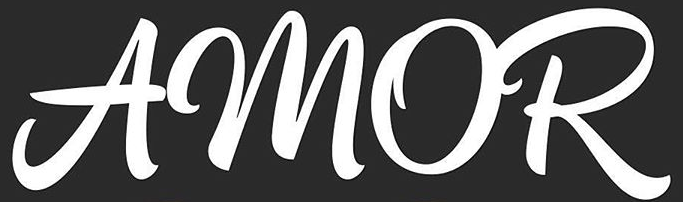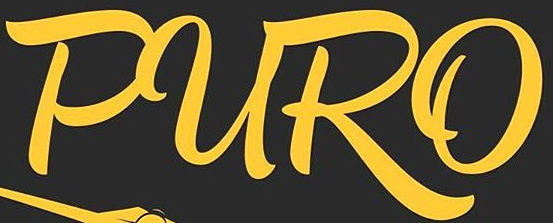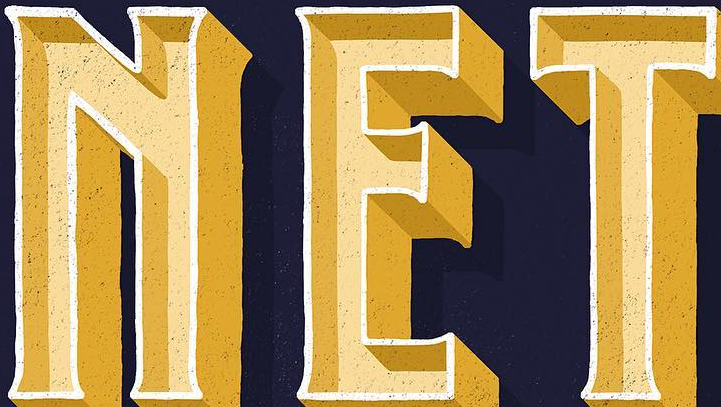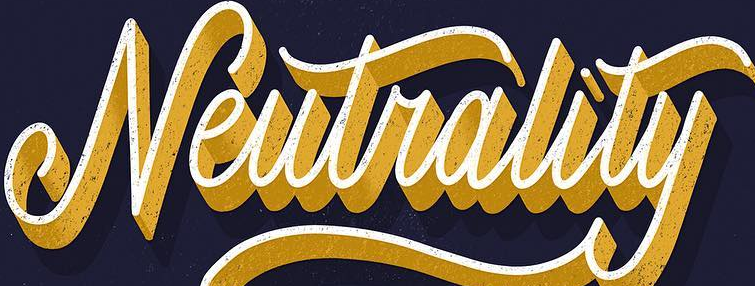Read the text from these images in sequence, separated by a semicolon. AMOR; PURO; NET; Neutrality 